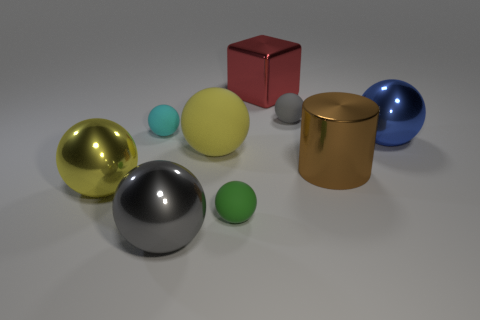The block that is the same size as the yellow rubber thing is what color?
Provide a succinct answer. Red. Do the red shiny cube and the brown object have the same size?
Provide a succinct answer. Yes. The other object that is the same color as the large rubber object is what shape?
Make the answer very short. Sphere. There is a brown metal cylinder; is it the same size as the rubber object on the right side of the large block?
Your answer should be compact. No. There is a sphere that is in front of the cyan matte thing and to the left of the gray shiny ball; what color is it?
Provide a short and direct response. Yellow. Is the number of small green rubber balls to the right of the big red thing greater than the number of large metal cylinders that are to the right of the big brown thing?
Keep it short and to the point. No. There is a cyan sphere that is the same material as the small green sphere; what size is it?
Your answer should be compact. Small. There is a large metallic object left of the gray shiny thing; how many big things are in front of it?
Your response must be concise. 1. Is there a large yellow object that has the same shape as the small cyan matte object?
Your response must be concise. Yes. What color is the rubber sphere that is in front of the large yellow ball on the left side of the gray metal thing?
Your response must be concise. Green. 